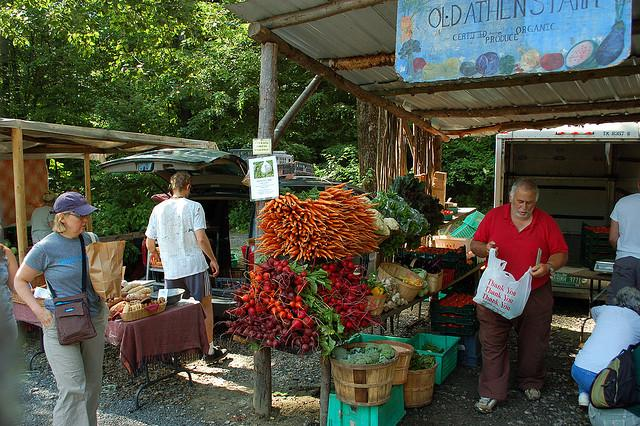Beta carotene rich vegetable in the image is?

Choices:
A) cabbage
B) broccoli
C) beet
D) carrot carrot 